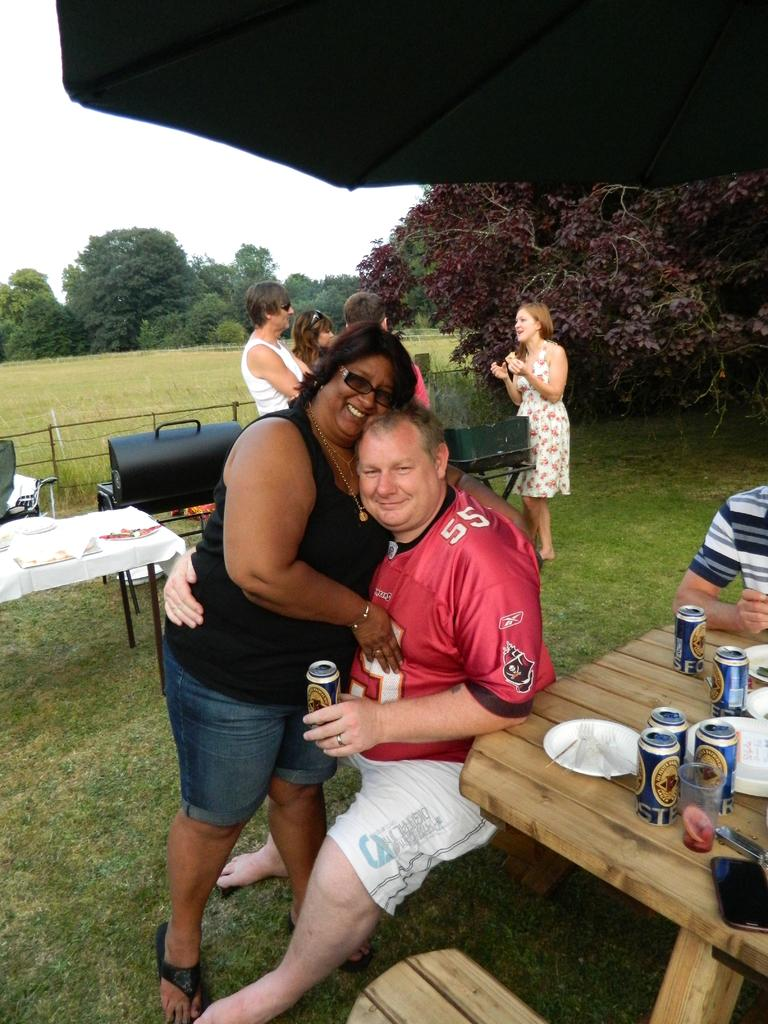Provide a one-sentence caption for the provided image. A woman hugging a man with the number 55 on his shirt. 